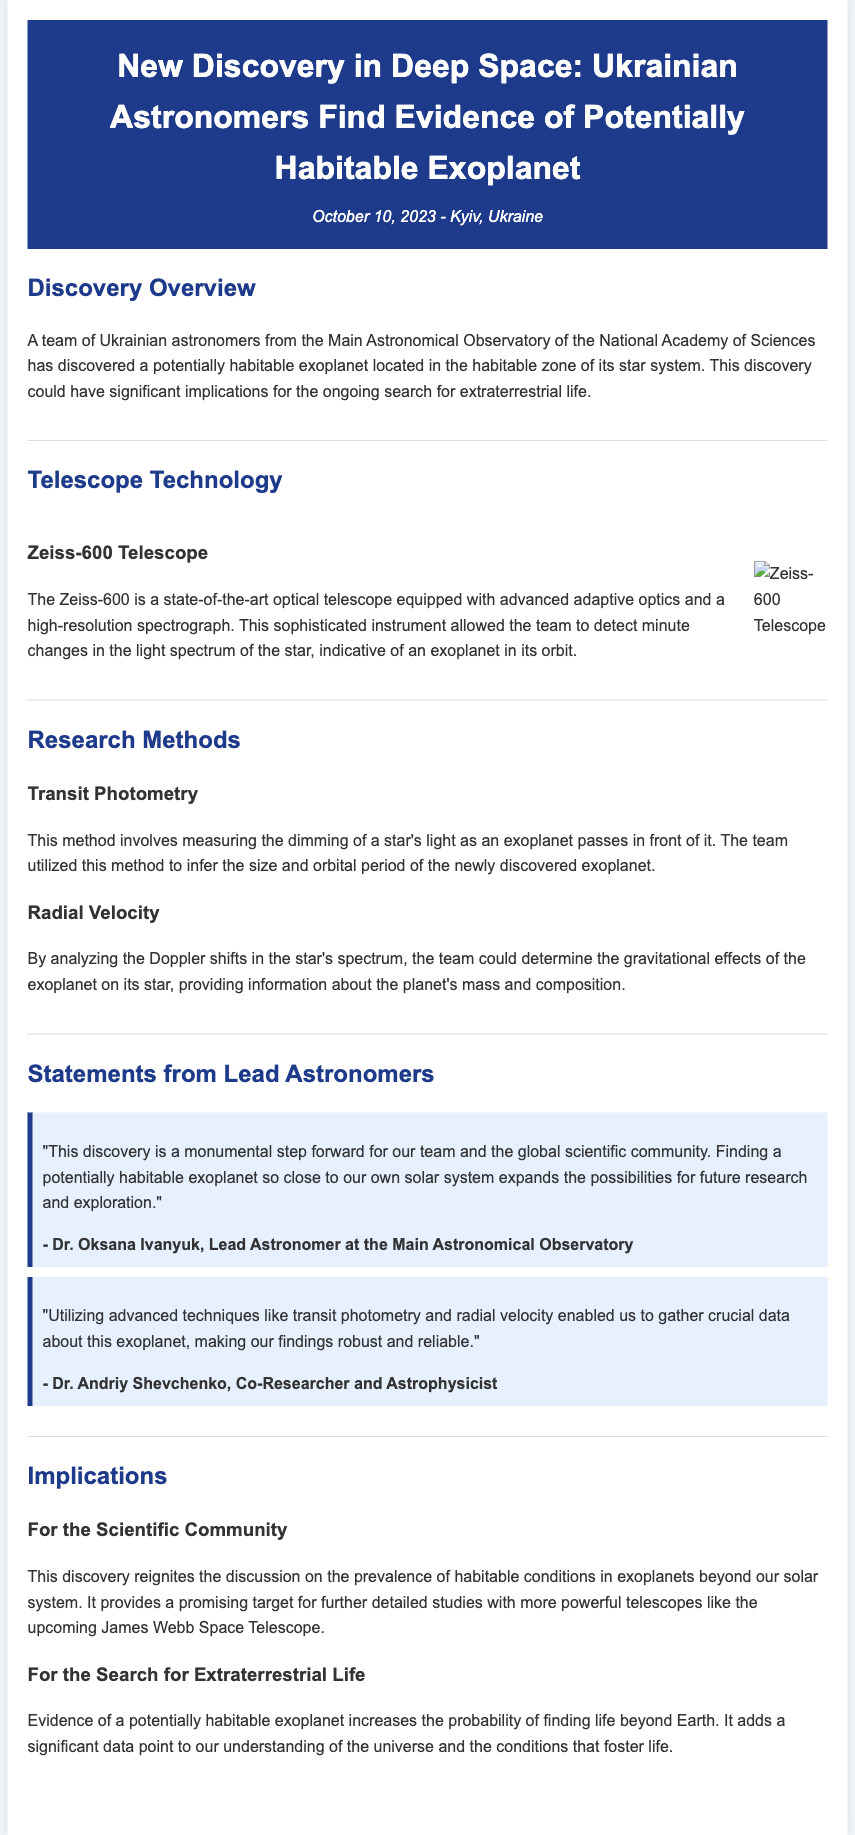What is the name of the telescope used in the discovery? The telescope mentioned in the release is the state-of-the-art optical telescope called Zeiss-600.
Answer: Zeiss-600 Who is the lead astronomer of the team? The lead astronomer cited in the document is Dr. Oksana Ivanyuk.
Answer: Dr. Oksana Ivanyuk What research method involves measuring the dimming of a star's light? The method that involves measuring dimming is called transit photometry.
Answer: Transit photometry On what date was the discovery announced? The discovery was announced on October 10, 2023.
Answer: October 10, 2023 What does the discovery potentially indicate about extraterrestrial life? The discovery increases the probability of finding life beyond Earth.
Answer: Increases the probability of finding life Which prominent telescope is mentioned for future studies of the exoplanet? The upcoming James Webb Space Telescope is mentioned for future studies.
Answer: James Webb Space Telescope What two advanced techniques were utilized in the research? The techniques mentioned are transit photometry and radial velocity.
Answer: Transit photometry and radial velocity What significance does this discovery hold for the scientific community? This discovery reignites the discussion on the prevalence of habitable conditions in exoplanets.
Answer: Reignites discussion on habitable conditions 